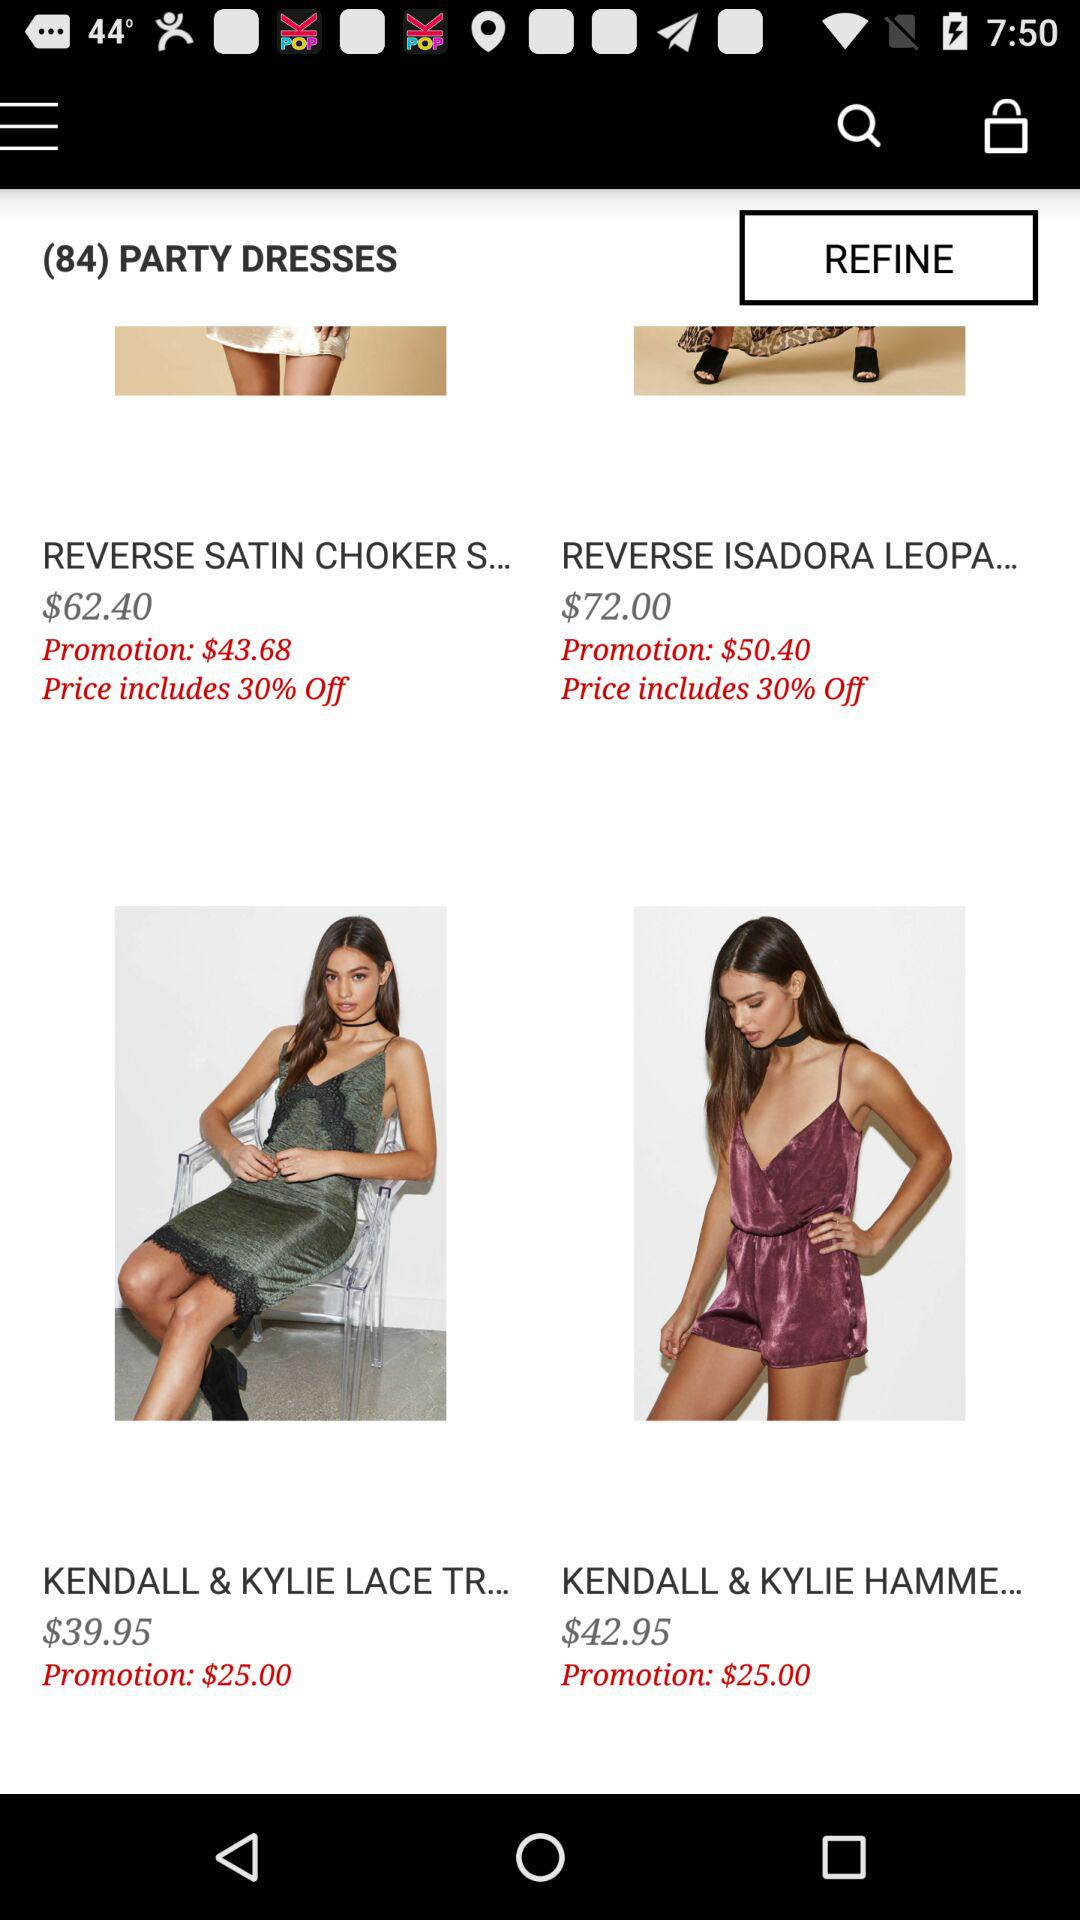What is the price of "KENDALL & KYLIE LACE TR..."? The price of "KENDALL & KYLIE LACE TR..." is $39.95. 